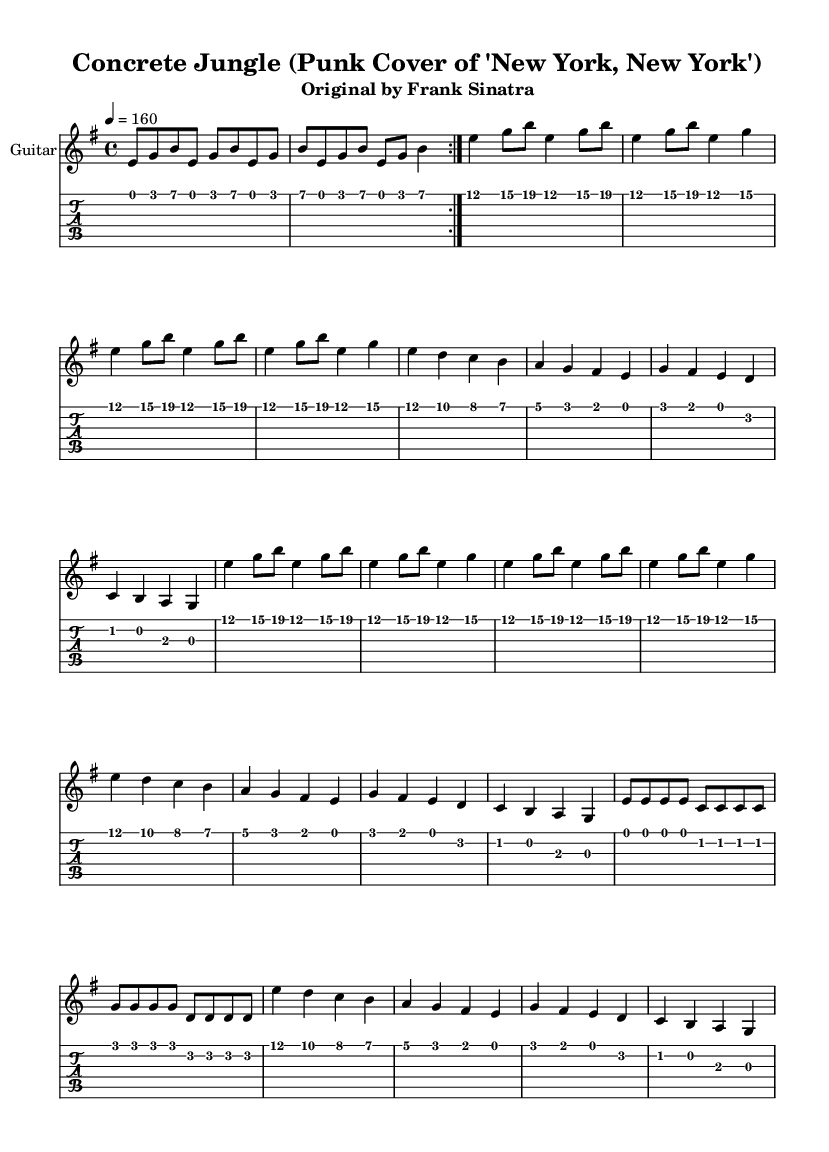What is the key signature of this music? The key signature is E minor, which contains one sharp (F#). This can be determined by examining the key signature notation at the beginning of the staff.
Answer: E minor What is the time signature of this piece? The time signature is 4/4, indicating four beats per measure, which can be seen at the beginning of the sheet music where the time signature is explicitly noted.
Answer: 4/4 What is the tempo marking of this composition? The tempo marking is indicated as “4 = 160,” meaning that there are 160 beats per minute, and this can be found at the start of the score under the global settings.
Answer: 160 How many times is the guitar riff repeated before the verse? The guitar riff is repeated twice before the verse starts, as shown by the “\repeat volta 2” notation preceding the guitar riff in the score.
Answer: 2 What is the first note of the chorus? The first note of the chorus is E, which is the starting note listed in the chorus section of the sheet music.
Answer: E How does the tempo of this punk cover compare to typical tempos in other genres? The tempo of this piece is upbeat at 160 BPM, which is a common characteristic of punk music, making it faster than genres like ballads or traditional pop. This higher tempo reflects the spirited and rebellious energy often found in punk.
Answer: 160 BPM 